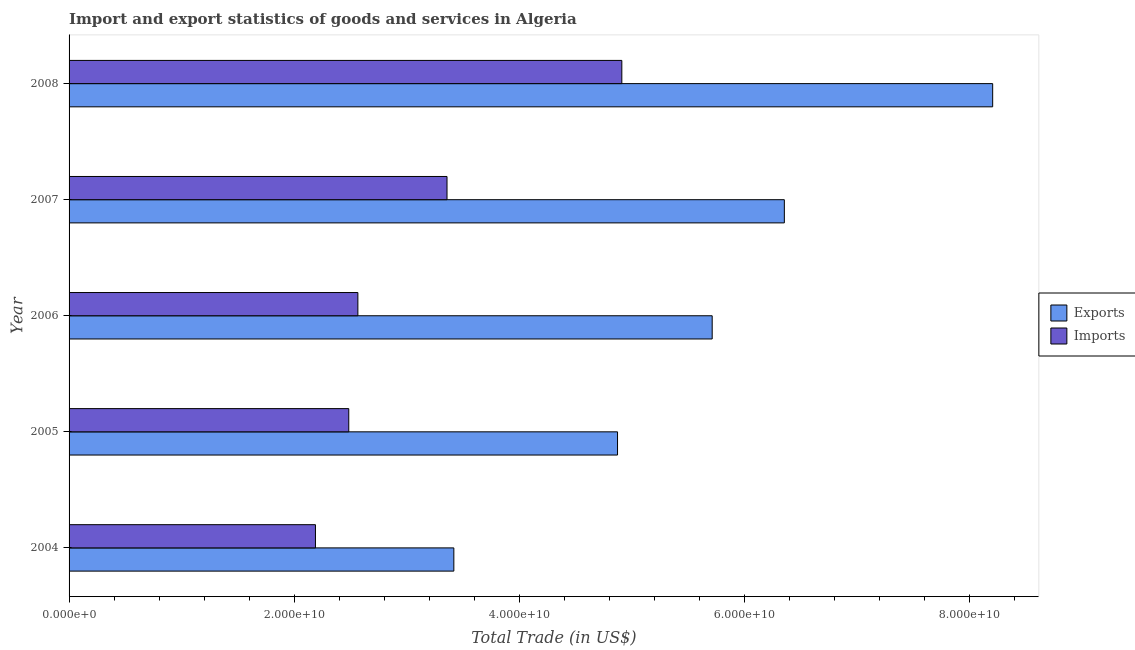How many groups of bars are there?
Keep it short and to the point. 5. Are the number of bars per tick equal to the number of legend labels?
Offer a very short reply. Yes. Are the number of bars on each tick of the Y-axis equal?
Keep it short and to the point. Yes. How many bars are there on the 5th tick from the bottom?
Ensure brevity in your answer.  2. What is the label of the 2nd group of bars from the top?
Your answer should be compact. 2007. What is the export of goods and services in 2005?
Make the answer very short. 4.87e+1. Across all years, what is the maximum export of goods and services?
Ensure brevity in your answer.  8.20e+1. Across all years, what is the minimum export of goods and services?
Your answer should be very brief. 3.42e+1. In which year was the export of goods and services maximum?
Make the answer very short. 2008. What is the total export of goods and services in the graph?
Keep it short and to the point. 2.86e+11. What is the difference between the imports of goods and services in 2004 and that in 2006?
Ensure brevity in your answer.  -3.77e+09. What is the difference between the imports of goods and services in 2008 and the export of goods and services in 2007?
Ensure brevity in your answer.  -1.44e+1. What is the average export of goods and services per year?
Keep it short and to the point. 5.71e+1. In the year 2008, what is the difference between the export of goods and services and imports of goods and services?
Make the answer very short. 3.29e+1. In how many years, is the imports of goods and services greater than 44000000000 US$?
Ensure brevity in your answer.  1. What is the ratio of the export of goods and services in 2004 to that in 2005?
Make the answer very short. 0.7. Is the imports of goods and services in 2006 less than that in 2008?
Your answer should be compact. Yes. Is the difference between the imports of goods and services in 2004 and 2006 greater than the difference between the export of goods and services in 2004 and 2006?
Make the answer very short. Yes. What is the difference between the highest and the second highest imports of goods and services?
Offer a very short reply. 1.55e+1. What is the difference between the highest and the lowest imports of goods and services?
Your answer should be very brief. 2.72e+1. What does the 1st bar from the top in 2004 represents?
Give a very brief answer. Imports. What does the 2nd bar from the bottom in 2004 represents?
Give a very brief answer. Imports. Are all the bars in the graph horizontal?
Your response must be concise. Yes. Where does the legend appear in the graph?
Provide a short and direct response. Center right. How many legend labels are there?
Ensure brevity in your answer.  2. How are the legend labels stacked?
Provide a succinct answer. Vertical. What is the title of the graph?
Offer a very short reply. Import and export statistics of goods and services in Algeria. What is the label or title of the X-axis?
Your answer should be compact. Total Trade (in US$). What is the Total Trade (in US$) of Exports in 2004?
Give a very brief answer. 3.42e+1. What is the Total Trade (in US$) of Imports in 2004?
Offer a very short reply. 2.19e+1. What is the Total Trade (in US$) in Exports in 2005?
Your response must be concise. 4.87e+1. What is the Total Trade (in US$) of Imports in 2005?
Offer a very short reply. 2.48e+1. What is the Total Trade (in US$) of Exports in 2006?
Your response must be concise. 5.71e+1. What is the Total Trade (in US$) of Imports in 2006?
Make the answer very short. 2.57e+1. What is the Total Trade (in US$) of Exports in 2007?
Offer a very short reply. 6.35e+1. What is the Total Trade (in US$) in Imports in 2007?
Your answer should be compact. 3.36e+1. What is the Total Trade (in US$) of Exports in 2008?
Give a very brief answer. 8.20e+1. What is the Total Trade (in US$) in Imports in 2008?
Offer a terse response. 4.91e+1. Across all years, what is the maximum Total Trade (in US$) in Exports?
Offer a very short reply. 8.20e+1. Across all years, what is the maximum Total Trade (in US$) of Imports?
Keep it short and to the point. 4.91e+1. Across all years, what is the minimum Total Trade (in US$) of Exports?
Provide a succinct answer. 3.42e+1. Across all years, what is the minimum Total Trade (in US$) in Imports?
Your response must be concise. 2.19e+1. What is the total Total Trade (in US$) in Exports in the graph?
Offer a very short reply. 2.86e+11. What is the total Total Trade (in US$) in Imports in the graph?
Provide a succinct answer. 1.55e+11. What is the difference between the Total Trade (in US$) of Exports in 2004 and that in 2005?
Offer a very short reply. -1.45e+1. What is the difference between the Total Trade (in US$) of Imports in 2004 and that in 2005?
Your response must be concise. -2.96e+09. What is the difference between the Total Trade (in US$) of Exports in 2004 and that in 2006?
Your answer should be compact. -2.29e+1. What is the difference between the Total Trade (in US$) of Imports in 2004 and that in 2006?
Your answer should be compact. -3.77e+09. What is the difference between the Total Trade (in US$) of Exports in 2004 and that in 2007?
Provide a succinct answer. -2.94e+1. What is the difference between the Total Trade (in US$) of Imports in 2004 and that in 2007?
Give a very brief answer. -1.17e+1. What is the difference between the Total Trade (in US$) of Exports in 2004 and that in 2008?
Offer a terse response. -4.79e+1. What is the difference between the Total Trade (in US$) in Imports in 2004 and that in 2008?
Your response must be concise. -2.72e+1. What is the difference between the Total Trade (in US$) of Exports in 2005 and that in 2006?
Ensure brevity in your answer.  -8.41e+09. What is the difference between the Total Trade (in US$) of Imports in 2005 and that in 2006?
Your answer should be very brief. -8.08e+08. What is the difference between the Total Trade (in US$) of Exports in 2005 and that in 2007?
Provide a short and direct response. -1.48e+1. What is the difference between the Total Trade (in US$) in Imports in 2005 and that in 2007?
Make the answer very short. -8.73e+09. What is the difference between the Total Trade (in US$) in Exports in 2005 and that in 2008?
Keep it short and to the point. -3.33e+1. What is the difference between the Total Trade (in US$) in Imports in 2005 and that in 2008?
Ensure brevity in your answer.  -2.43e+1. What is the difference between the Total Trade (in US$) in Exports in 2006 and that in 2007?
Give a very brief answer. -6.41e+09. What is the difference between the Total Trade (in US$) of Imports in 2006 and that in 2007?
Your response must be concise. -7.92e+09. What is the difference between the Total Trade (in US$) in Exports in 2006 and that in 2008?
Make the answer very short. -2.49e+1. What is the difference between the Total Trade (in US$) of Imports in 2006 and that in 2008?
Provide a short and direct response. -2.34e+1. What is the difference between the Total Trade (in US$) in Exports in 2007 and that in 2008?
Make the answer very short. -1.85e+1. What is the difference between the Total Trade (in US$) in Imports in 2007 and that in 2008?
Your response must be concise. -1.55e+1. What is the difference between the Total Trade (in US$) in Exports in 2004 and the Total Trade (in US$) in Imports in 2005?
Your response must be concise. 9.33e+09. What is the difference between the Total Trade (in US$) of Exports in 2004 and the Total Trade (in US$) of Imports in 2006?
Ensure brevity in your answer.  8.52e+09. What is the difference between the Total Trade (in US$) of Exports in 2004 and the Total Trade (in US$) of Imports in 2007?
Offer a very short reply. 6.07e+08. What is the difference between the Total Trade (in US$) in Exports in 2004 and the Total Trade (in US$) in Imports in 2008?
Provide a short and direct response. -1.49e+1. What is the difference between the Total Trade (in US$) in Exports in 2005 and the Total Trade (in US$) in Imports in 2006?
Your answer should be compact. 2.31e+1. What is the difference between the Total Trade (in US$) in Exports in 2005 and the Total Trade (in US$) in Imports in 2007?
Give a very brief answer. 1.51e+1. What is the difference between the Total Trade (in US$) of Exports in 2005 and the Total Trade (in US$) of Imports in 2008?
Provide a short and direct response. -3.81e+08. What is the difference between the Total Trade (in US$) of Exports in 2006 and the Total Trade (in US$) of Imports in 2007?
Your answer should be very brief. 2.36e+1. What is the difference between the Total Trade (in US$) of Exports in 2006 and the Total Trade (in US$) of Imports in 2008?
Your answer should be compact. 8.03e+09. What is the difference between the Total Trade (in US$) in Exports in 2007 and the Total Trade (in US$) in Imports in 2008?
Keep it short and to the point. 1.44e+1. What is the average Total Trade (in US$) in Exports per year?
Your answer should be compact. 5.71e+1. What is the average Total Trade (in US$) of Imports per year?
Offer a terse response. 3.10e+1. In the year 2004, what is the difference between the Total Trade (in US$) of Exports and Total Trade (in US$) of Imports?
Keep it short and to the point. 1.23e+1. In the year 2005, what is the difference between the Total Trade (in US$) of Exports and Total Trade (in US$) of Imports?
Provide a succinct answer. 2.39e+1. In the year 2006, what is the difference between the Total Trade (in US$) in Exports and Total Trade (in US$) in Imports?
Make the answer very short. 3.15e+1. In the year 2007, what is the difference between the Total Trade (in US$) in Exports and Total Trade (in US$) in Imports?
Your response must be concise. 3.00e+1. In the year 2008, what is the difference between the Total Trade (in US$) in Exports and Total Trade (in US$) in Imports?
Provide a short and direct response. 3.29e+1. What is the ratio of the Total Trade (in US$) of Exports in 2004 to that in 2005?
Keep it short and to the point. 0.7. What is the ratio of the Total Trade (in US$) in Imports in 2004 to that in 2005?
Give a very brief answer. 0.88. What is the ratio of the Total Trade (in US$) in Exports in 2004 to that in 2006?
Give a very brief answer. 0.6. What is the ratio of the Total Trade (in US$) in Imports in 2004 to that in 2006?
Provide a succinct answer. 0.85. What is the ratio of the Total Trade (in US$) of Exports in 2004 to that in 2007?
Offer a terse response. 0.54. What is the ratio of the Total Trade (in US$) in Imports in 2004 to that in 2007?
Give a very brief answer. 0.65. What is the ratio of the Total Trade (in US$) in Exports in 2004 to that in 2008?
Offer a very short reply. 0.42. What is the ratio of the Total Trade (in US$) in Imports in 2004 to that in 2008?
Offer a terse response. 0.45. What is the ratio of the Total Trade (in US$) of Exports in 2005 to that in 2006?
Make the answer very short. 0.85. What is the ratio of the Total Trade (in US$) in Imports in 2005 to that in 2006?
Provide a short and direct response. 0.97. What is the ratio of the Total Trade (in US$) in Exports in 2005 to that in 2007?
Ensure brevity in your answer.  0.77. What is the ratio of the Total Trade (in US$) in Imports in 2005 to that in 2007?
Offer a terse response. 0.74. What is the ratio of the Total Trade (in US$) in Exports in 2005 to that in 2008?
Ensure brevity in your answer.  0.59. What is the ratio of the Total Trade (in US$) in Imports in 2005 to that in 2008?
Give a very brief answer. 0.51. What is the ratio of the Total Trade (in US$) of Exports in 2006 to that in 2007?
Make the answer very short. 0.9. What is the ratio of the Total Trade (in US$) in Imports in 2006 to that in 2007?
Your response must be concise. 0.76. What is the ratio of the Total Trade (in US$) of Exports in 2006 to that in 2008?
Offer a very short reply. 0.7. What is the ratio of the Total Trade (in US$) in Imports in 2006 to that in 2008?
Offer a very short reply. 0.52. What is the ratio of the Total Trade (in US$) of Exports in 2007 to that in 2008?
Your answer should be compact. 0.77. What is the ratio of the Total Trade (in US$) in Imports in 2007 to that in 2008?
Offer a terse response. 0.68. What is the difference between the highest and the second highest Total Trade (in US$) in Exports?
Your answer should be very brief. 1.85e+1. What is the difference between the highest and the second highest Total Trade (in US$) in Imports?
Ensure brevity in your answer.  1.55e+1. What is the difference between the highest and the lowest Total Trade (in US$) of Exports?
Make the answer very short. 4.79e+1. What is the difference between the highest and the lowest Total Trade (in US$) in Imports?
Make the answer very short. 2.72e+1. 